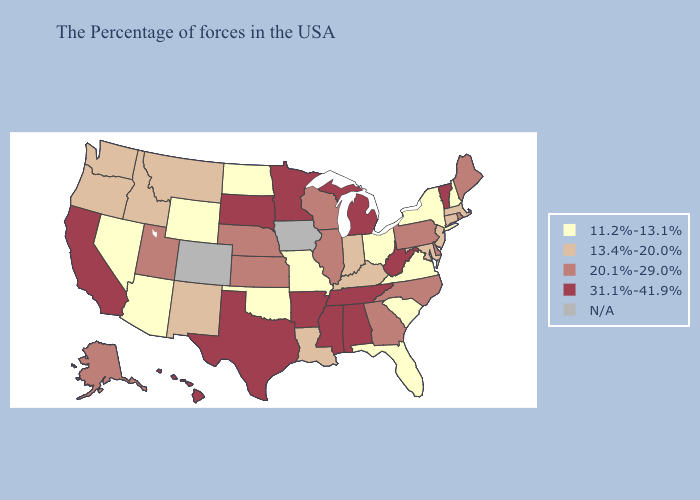Name the states that have a value in the range 31.1%-41.9%?
Give a very brief answer. Vermont, West Virginia, Michigan, Alabama, Tennessee, Mississippi, Arkansas, Minnesota, Texas, South Dakota, California, Hawaii. What is the highest value in the South ?
Short answer required. 31.1%-41.9%. What is the lowest value in the Northeast?
Write a very short answer. 11.2%-13.1%. What is the value of Colorado?
Short answer required. N/A. What is the lowest value in states that border Maine?
Answer briefly. 11.2%-13.1%. Among the states that border Michigan , does Indiana have the lowest value?
Short answer required. No. Does Massachusetts have the lowest value in the USA?
Quick response, please. No. Does the map have missing data?
Answer briefly. Yes. What is the highest value in the South ?
Give a very brief answer. 31.1%-41.9%. Name the states that have a value in the range 20.1%-29.0%?
Concise answer only. Maine, Rhode Island, Delaware, Pennsylvania, North Carolina, Georgia, Wisconsin, Illinois, Kansas, Nebraska, Utah, Alaska. What is the value of Texas?
Write a very short answer. 31.1%-41.9%. Which states hav the highest value in the South?
Be succinct. West Virginia, Alabama, Tennessee, Mississippi, Arkansas, Texas. Does the map have missing data?
Give a very brief answer. Yes. What is the lowest value in the USA?
Keep it brief. 11.2%-13.1%. 